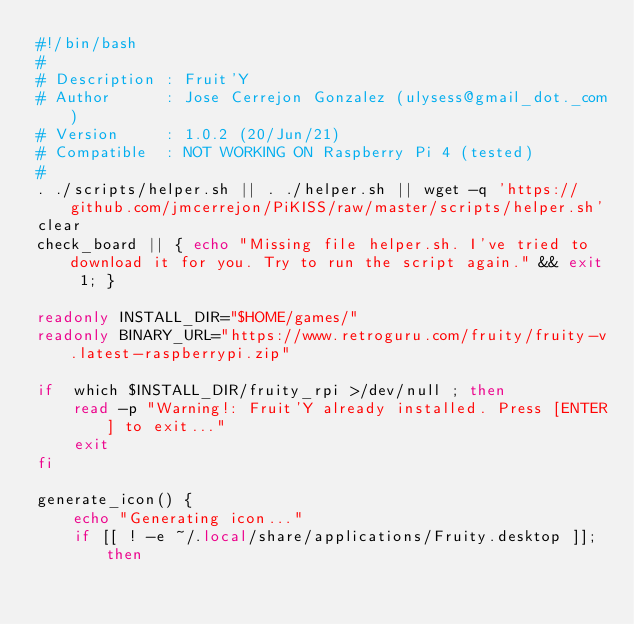Convert code to text. <code><loc_0><loc_0><loc_500><loc_500><_Bash_>#!/bin/bash
#
# Description : Fruit'Y
# Author      : Jose Cerrejon Gonzalez (ulysess@gmail_dot._com)
# Version     : 1.0.2 (20/Jun/21)
# Compatible  : NOT WORKING ON Raspberry Pi 4 (tested)
#
. ./scripts/helper.sh || . ./helper.sh || wget -q 'https://github.com/jmcerrejon/PiKISS/raw/master/scripts/helper.sh'
clear
check_board || { echo "Missing file helper.sh. I've tried to download it for you. Try to run the script again." && exit 1; }

readonly INSTALL_DIR="$HOME/games/"
readonly BINARY_URL="https://www.retroguru.com/fruity/fruity-v.latest-raspberrypi.zip"

if  which $INSTALL_DIR/fruity_rpi >/dev/null ; then
    read -p "Warning!: Fruit'Y already installed. Press [ENTER] to exit..."
    exit
fi

generate_icon() {
    echo "Generating icon..."
    if [[ ! -e ~/.local/share/applications/Fruity.desktop ]]; then</code> 